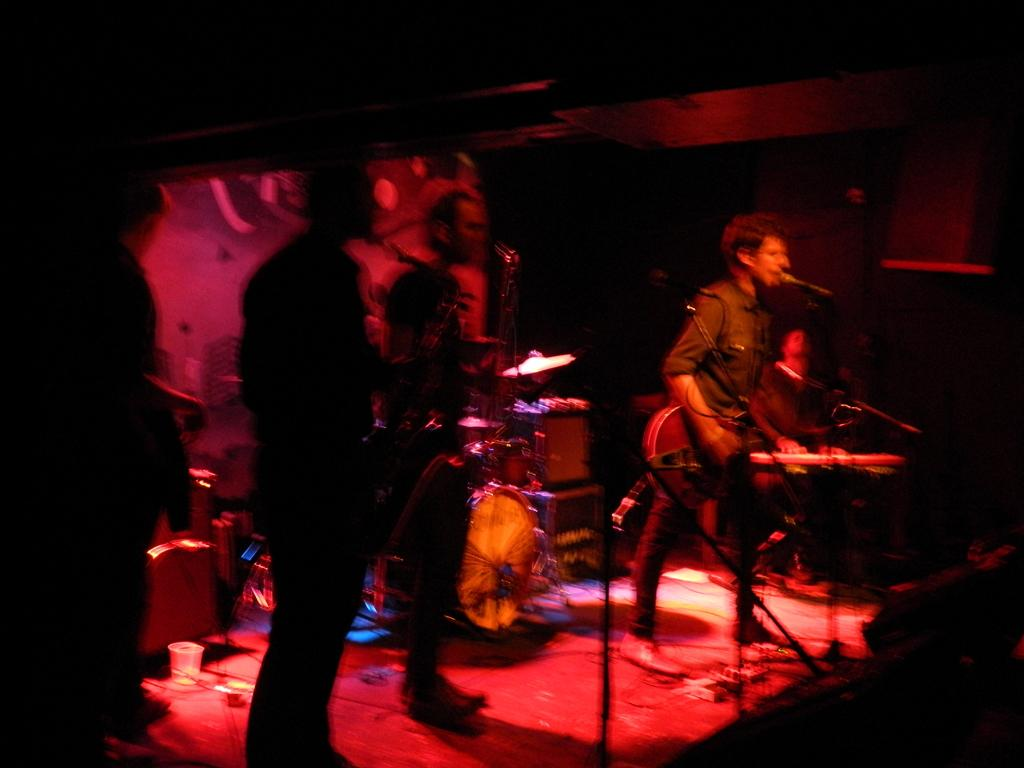How many people are in the image? There are two persons in the image. What are the two persons doing? They are playing guitar and singing. Where are they located in relation to the microphone? They are in front of a microphone. What is the position of one of the persons? One person is standing. What other objects related to music can be seen in the image? There are musical instruments in the image. What type of design can be seen on the minister's robe in the image? There is no minister or robe present in the image. What town is depicted in the background of the image? There is no town visible in the image; it focuses on the two persons playing music. 